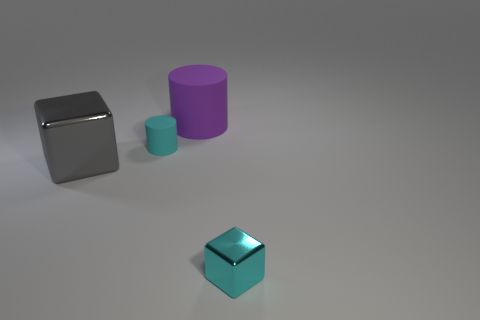Add 3 yellow things. How many objects exist? 7 Add 3 small gray metallic spheres. How many small gray metallic spheres exist? 3 Subtract 0 green cubes. How many objects are left? 4 Subtract all big gray shiny balls. Subtract all big things. How many objects are left? 2 Add 2 tiny cyan matte objects. How many tiny cyan matte objects are left? 3 